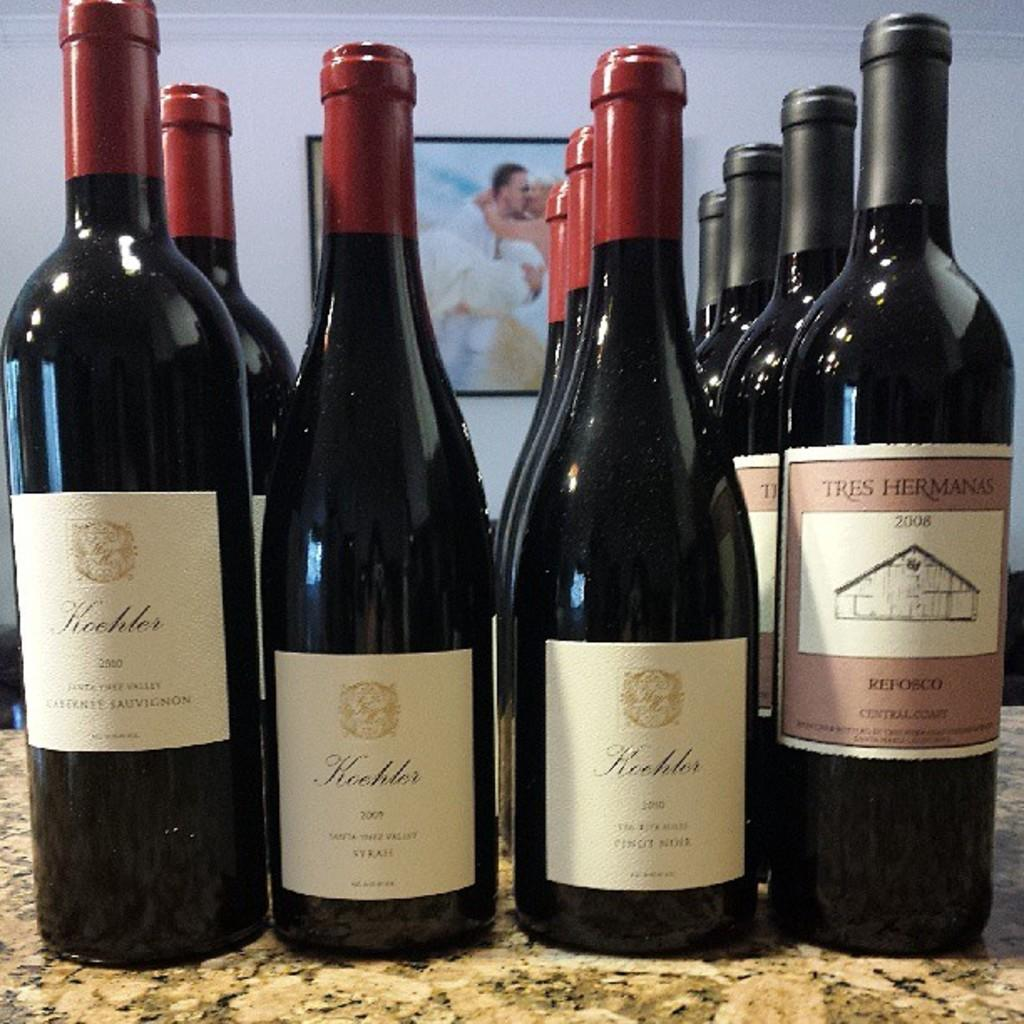<image>
Relay a brief, clear account of the picture shown. a bottle that has koebler on the front of it 